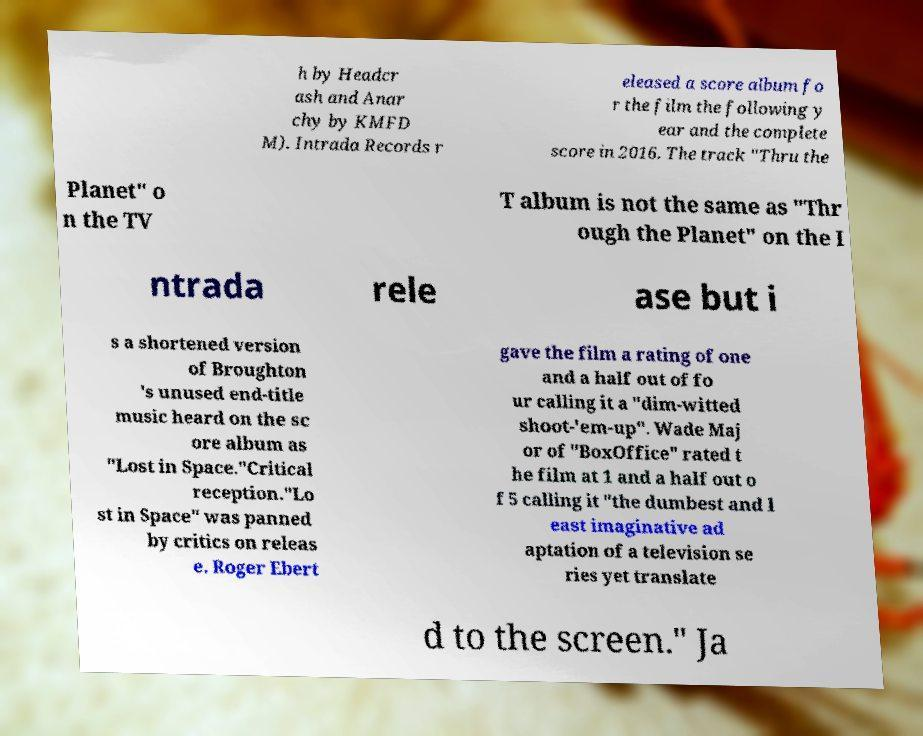For documentation purposes, I need the text within this image transcribed. Could you provide that? h by Headcr ash and Anar chy by KMFD M). Intrada Records r eleased a score album fo r the film the following y ear and the complete score in 2016. The track "Thru the Planet" o n the TV T album is not the same as "Thr ough the Planet" on the I ntrada rele ase but i s a shortened version of Broughton 's unused end-title music heard on the sc ore album as "Lost in Space."Critical reception."Lo st in Space" was panned by critics on releas e. Roger Ebert gave the film a rating of one and a half out of fo ur calling it a "dim-witted shoot-'em-up". Wade Maj or of "BoxOffice" rated t he film at 1 and a half out o f 5 calling it "the dumbest and l east imaginative ad aptation of a television se ries yet translate d to the screen." Ja 